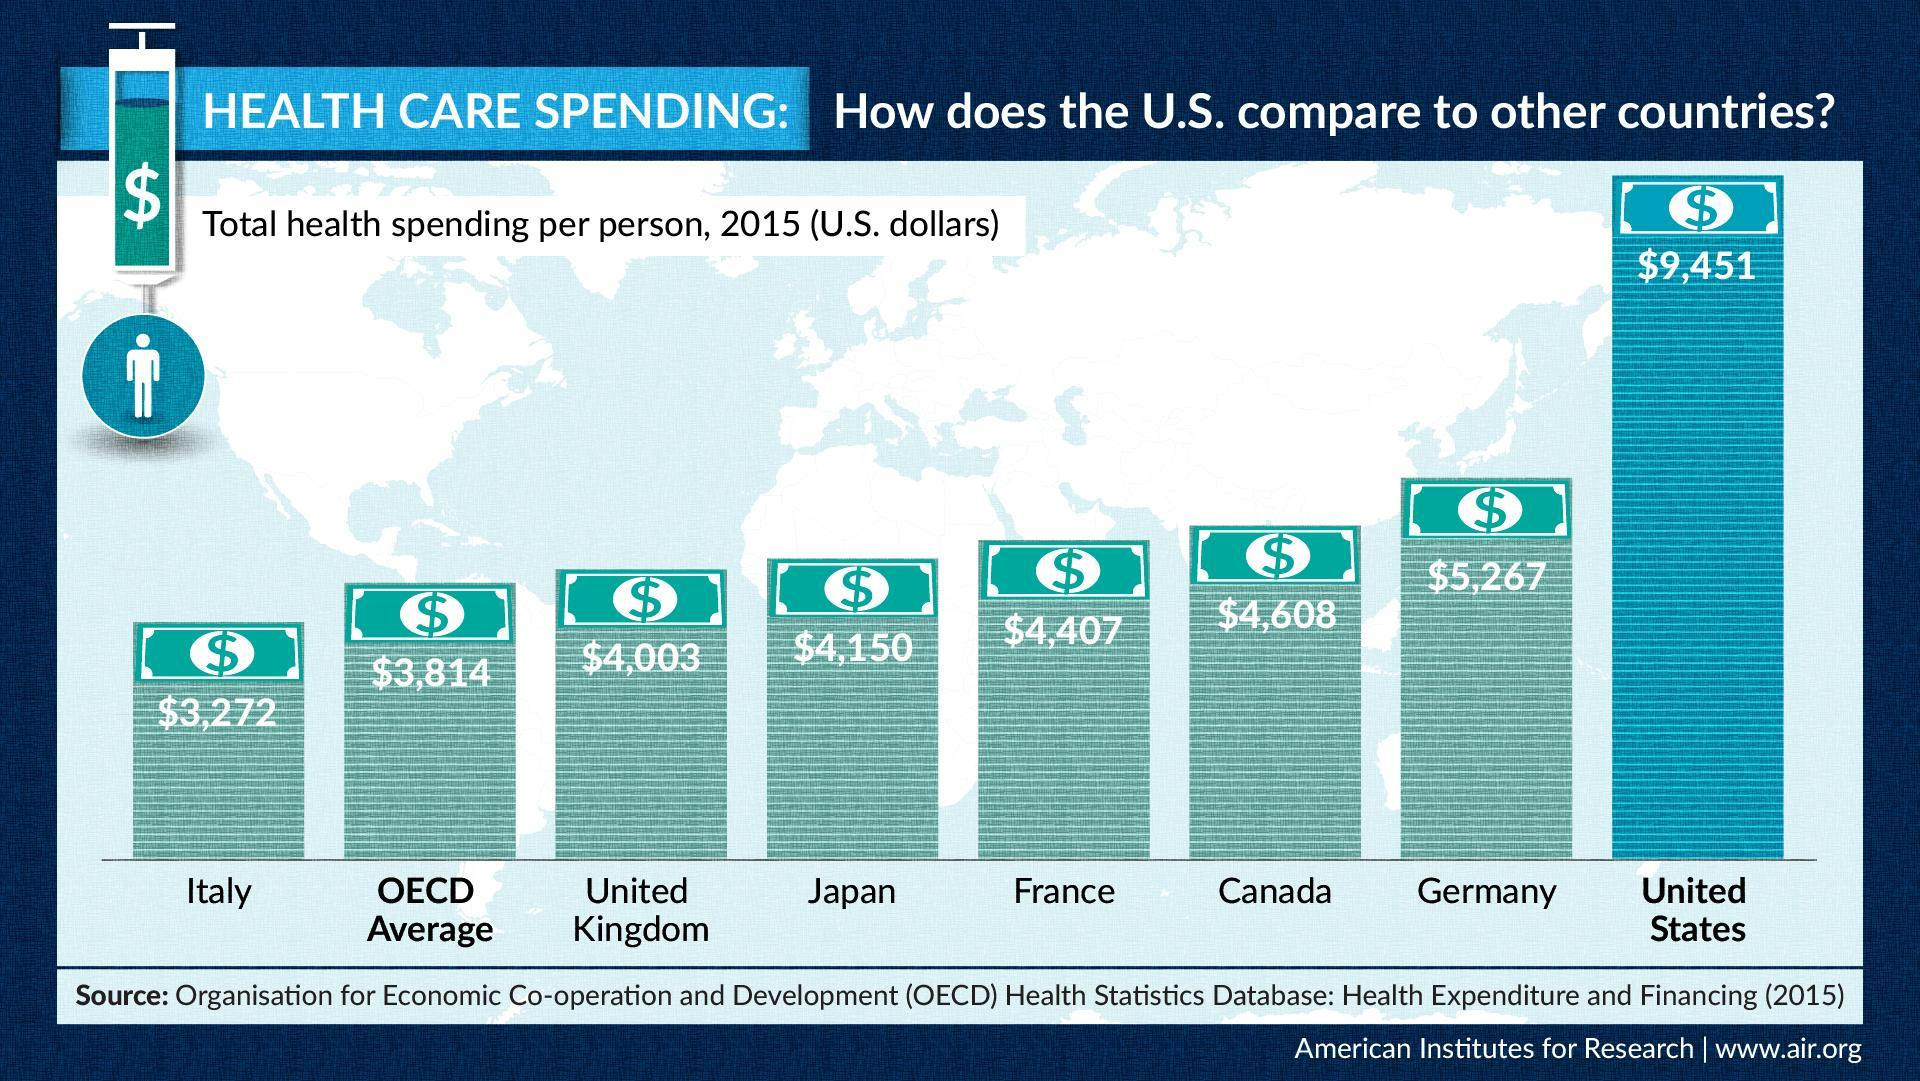What is the total health spending per person (U.S. dollars) in U.S. in the year 2015?
Answer the question with a short phrase. $9,451 What is the total health spending per person (U.S. dollars) in Japan in the year 2015? $4,150 Which country has recorded the lowest total health spending per person in the year 2015 compared to U.S? Italy Which country has recorded the highest total health spending per person in the year 2015 after the U.S.? Germany 